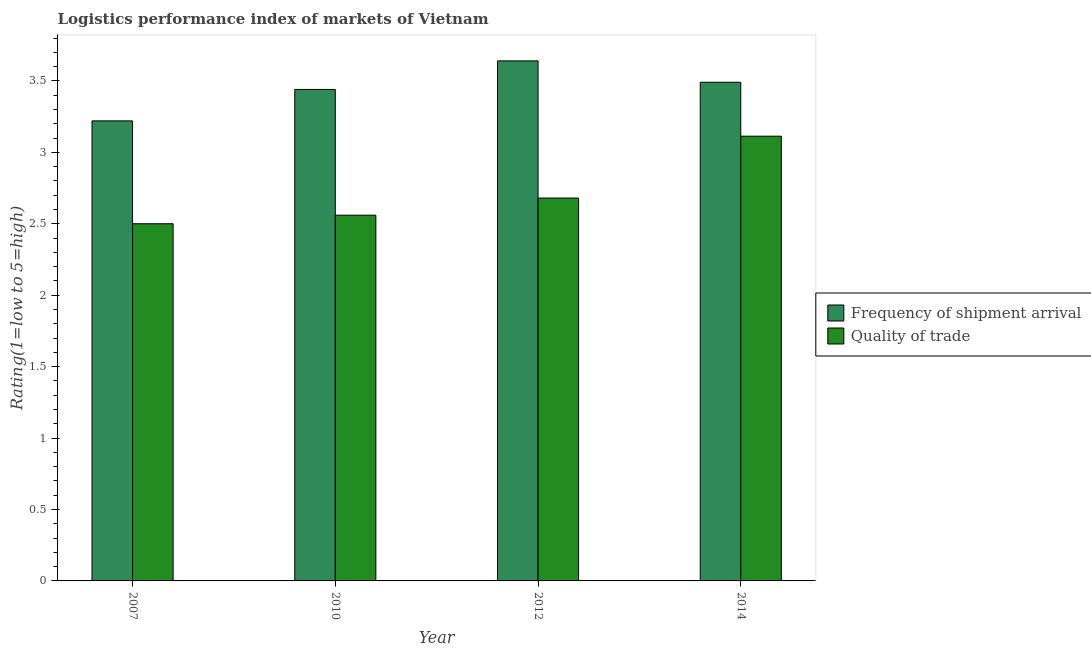How many different coloured bars are there?
Provide a short and direct response. 2. Are the number of bars per tick equal to the number of legend labels?
Your answer should be very brief. Yes. Are the number of bars on each tick of the X-axis equal?
Your answer should be compact. Yes. How many bars are there on the 2nd tick from the right?
Make the answer very short. 2. What is the label of the 1st group of bars from the left?
Offer a terse response. 2007. What is the lpi of frequency of shipment arrival in 2007?
Keep it short and to the point. 3.22. Across all years, what is the maximum lpi quality of trade?
Give a very brief answer. 3.11. Across all years, what is the minimum lpi of frequency of shipment arrival?
Offer a terse response. 3.22. In which year was the lpi of frequency of shipment arrival maximum?
Your answer should be very brief. 2012. What is the total lpi quality of trade in the graph?
Offer a very short reply. 10.85. What is the difference between the lpi quality of trade in 2010 and that in 2014?
Your response must be concise. -0.55. What is the difference between the lpi quality of trade in 2010 and the lpi of frequency of shipment arrival in 2007?
Provide a short and direct response. 0.06. What is the average lpi of frequency of shipment arrival per year?
Give a very brief answer. 3.45. What is the ratio of the lpi quality of trade in 2012 to that in 2014?
Make the answer very short. 0.86. Is the difference between the lpi of frequency of shipment arrival in 2010 and 2012 greater than the difference between the lpi quality of trade in 2010 and 2012?
Offer a terse response. No. What is the difference between the highest and the second highest lpi of frequency of shipment arrival?
Provide a short and direct response. 0.15. What is the difference between the highest and the lowest lpi of frequency of shipment arrival?
Your answer should be compact. 0.42. In how many years, is the lpi of frequency of shipment arrival greater than the average lpi of frequency of shipment arrival taken over all years?
Ensure brevity in your answer.  2. Is the sum of the lpi quality of trade in 2007 and 2014 greater than the maximum lpi of frequency of shipment arrival across all years?
Your response must be concise. Yes. What does the 1st bar from the left in 2010 represents?
Your answer should be very brief. Frequency of shipment arrival. What does the 1st bar from the right in 2014 represents?
Your answer should be very brief. Quality of trade. Are all the bars in the graph horizontal?
Keep it short and to the point. No. How many years are there in the graph?
Ensure brevity in your answer.  4. What is the difference between two consecutive major ticks on the Y-axis?
Your response must be concise. 0.5. Does the graph contain grids?
Your response must be concise. No. Where does the legend appear in the graph?
Provide a short and direct response. Center right. What is the title of the graph?
Offer a very short reply. Logistics performance index of markets of Vietnam. What is the label or title of the Y-axis?
Offer a very short reply. Rating(1=low to 5=high). What is the Rating(1=low to 5=high) in Frequency of shipment arrival in 2007?
Ensure brevity in your answer.  3.22. What is the Rating(1=low to 5=high) in Quality of trade in 2007?
Make the answer very short. 2.5. What is the Rating(1=low to 5=high) in Frequency of shipment arrival in 2010?
Give a very brief answer. 3.44. What is the Rating(1=low to 5=high) of Quality of trade in 2010?
Make the answer very short. 2.56. What is the Rating(1=low to 5=high) of Frequency of shipment arrival in 2012?
Give a very brief answer. 3.64. What is the Rating(1=low to 5=high) in Quality of trade in 2012?
Keep it short and to the point. 2.68. What is the Rating(1=low to 5=high) of Frequency of shipment arrival in 2014?
Give a very brief answer. 3.49. What is the Rating(1=low to 5=high) in Quality of trade in 2014?
Give a very brief answer. 3.11. Across all years, what is the maximum Rating(1=low to 5=high) of Frequency of shipment arrival?
Ensure brevity in your answer.  3.64. Across all years, what is the maximum Rating(1=low to 5=high) in Quality of trade?
Make the answer very short. 3.11. Across all years, what is the minimum Rating(1=low to 5=high) of Frequency of shipment arrival?
Make the answer very short. 3.22. What is the total Rating(1=low to 5=high) of Frequency of shipment arrival in the graph?
Offer a terse response. 13.79. What is the total Rating(1=low to 5=high) of Quality of trade in the graph?
Provide a succinct answer. 10.85. What is the difference between the Rating(1=low to 5=high) of Frequency of shipment arrival in 2007 and that in 2010?
Your answer should be very brief. -0.22. What is the difference between the Rating(1=low to 5=high) in Quality of trade in 2007 and that in 2010?
Make the answer very short. -0.06. What is the difference between the Rating(1=low to 5=high) of Frequency of shipment arrival in 2007 and that in 2012?
Your answer should be very brief. -0.42. What is the difference between the Rating(1=low to 5=high) of Quality of trade in 2007 and that in 2012?
Ensure brevity in your answer.  -0.18. What is the difference between the Rating(1=low to 5=high) of Frequency of shipment arrival in 2007 and that in 2014?
Provide a succinct answer. -0.27. What is the difference between the Rating(1=low to 5=high) in Quality of trade in 2007 and that in 2014?
Keep it short and to the point. -0.61. What is the difference between the Rating(1=low to 5=high) in Frequency of shipment arrival in 2010 and that in 2012?
Your response must be concise. -0.2. What is the difference between the Rating(1=low to 5=high) of Quality of trade in 2010 and that in 2012?
Your answer should be compact. -0.12. What is the difference between the Rating(1=low to 5=high) in Frequency of shipment arrival in 2010 and that in 2014?
Your response must be concise. -0.05. What is the difference between the Rating(1=low to 5=high) in Quality of trade in 2010 and that in 2014?
Make the answer very short. -0.55. What is the difference between the Rating(1=low to 5=high) of Frequency of shipment arrival in 2012 and that in 2014?
Offer a very short reply. 0.15. What is the difference between the Rating(1=low to 5=high) in Quality of trade in 2012 and that in 2014?
Your answer should be very brief. -0.43. What is the difference between the Rating(1=low to 5=high) of Frequency of shipment arrival in 2007 and the Rating(1=low to 5=high) of Quality of trade in 2010?
Ensure brevity in your answer.  0.66. What is the difference between the Rating(1=low to 5=high) in Frequency of shipment arrival in 2007 and the Rating(1=low to 5=high) in Quality of trade in 2012?
Ensure brevity in your answer.  0.54. What is the difference between the Rating(1=low to 5=high) in Frequency of shipment arrival in 2007 and the Rating(1=low to 5=high) in Quality of trade in 2014?
Keep it short and to the point. 0.11. What is the difference between the Rating(1=low to 5=high) of Frequency of shipment arrival in 2010 and the Rating(1=low to 5=high) of Quality of trade in 2012?
Your answer should be compact. 0.76. What is the difference between the Rating(1=low to 5=high) of Frequency of shipment arrival in 2010 and the Rating(1=low to 5=high) of Quality of trade in 2014?
Offer a terse response. 0.33. What is the difference between the Rating(1=low to 5=high) of Frequency of shipment arrival in 2012 and the Rating(1=low to 5=high) of Quality of trade in 2014?
Offer a very short reply. 0.53. What is the average Rating(1=low to 5=high) in Frequency of shipment arrival per year?
Your answer should be compact. 3.45. What is the average Rating(1=low to 5=high) in Quality of trade per year?
Make the answer very short. 2.71. In the year 2007, what is the difference between the Rating(1=low to 5=high) in Frequency of shipment arrival and Rating(1=low to 5=high) in Quality of trade?
Ensure brevity in your answer.  0.72. In the year 2010, what is the difference between the Rating(1=low to 5=high) of Frequency of shipment arrival and Rating(1=low to 5=high) of Quality of trade?
Offer a very short reply. 0.88. In the year 2014, what is the difference between the Rating(1=low to 5=high) of Frequency of shipment arrival and Rating(1=low to 5=high) of Quality of trade?
Offer a very short reply. 0.38. What is the ratio of the Rating(1=low to 5=high) of Frequency of shipment arrival in 2007 to that in 2010?
Your answer should be very brief. 0.94. What is the ratio of the Rating(1=low to 5=high) of Quality of trade in 2007 to that in 2010?
Offer a very short reply. 0.98. What is the ratio of the Rating(1=low to 5=high) of Frequency of shipment arrival in 2007 to that in 2012?
Your answer should be very brief. 0.88. What is the ratio of the Rating(1=low to 5=high) of Quality of trade in 2007 to that in 2012?
Provide a succinct answer. 0.93. What is the ratio of the Rating(1=low to 5=high) of Frequency of shipment arrival in 2007 to that in 2014?
Keep it short and to the point. 0.92. What is the ratio of the Rating(1=low to 5=high) in Quality of trade in 2007 to that in 2014?
Your response must be concise. 0.8. What is the ratio of the Rating(1=low to 5=high) of Frequency of shipment arrival in 2010 to that in 2012?
Give a very brief answer. 0.95. What is the ratio of the Rating(1=low to 5=high) of Quality of trade in 2010 to that in 2012?
Offer a very short reply. 0.96. What is the ratio of the Rating(1=low to 5=high) of Frequency of shipment arrival in 2010 to that in 2014?
Offer a terse response. 0.99. What is the ratio of the Rating(1=low to 5=high) of Quality of trade in 2010 to that in 2014?
Make the answer very short. 0.82. What is the ratio of the Rating(1=low to 5=high) of Frequency of shipment arrival in 2012 to that in 2014?
Your answer should be compact. 1.04. What is the ratio of the Rating(1=low to 5=high) in Quality of trade in 2012 to that in 2014?
Provide a succinct answer. 0.86. What is the difference between the highest and the second highest Rating(1=low to 5=high) in Frequency of shipment arrival?
Provide a succinct answer. 0.15. What is the difference between the highest and the second highest Rating(1=low to 5=high) in Quality of trade?
Give a very brief answer. 0.43. What is the difference between the highest and the lowest Rating(1=low to 5=high) of Frequency of shipment arrival?
Offer a very short reply. 0.42. What is the difference between the highest and the lowest Rating(1=low to 5=high) in Quality of trade?
Your answer should be very brief. 0.61. 